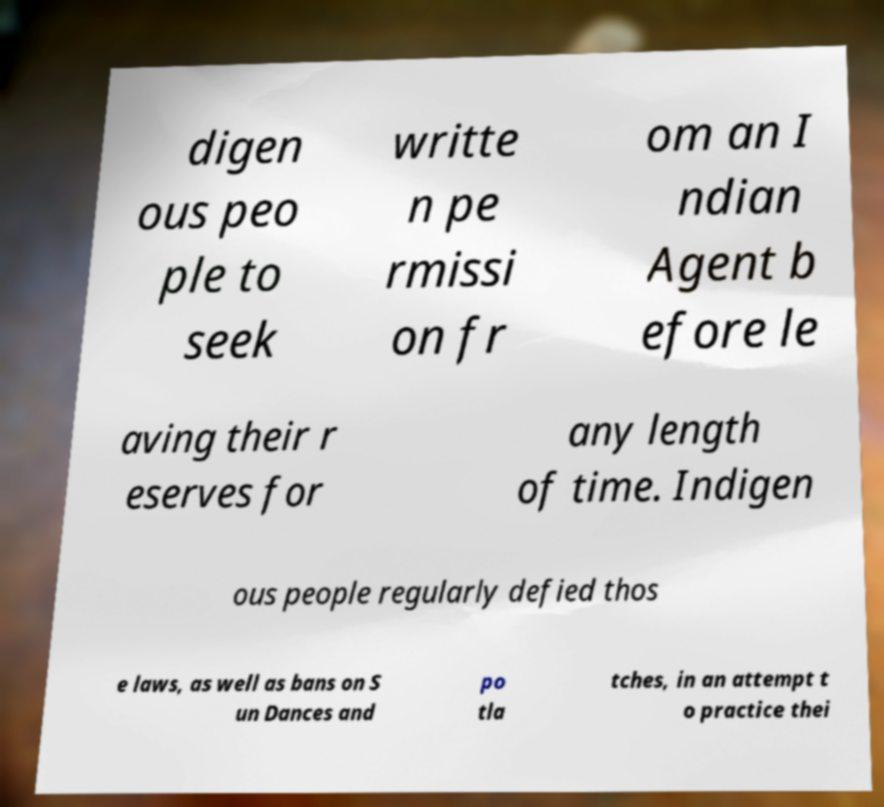Can you read and provide the text displayed in the image?This photo seems to have some interesting text. Can you extract and type it out for me? digen ous peo ple to seek writte n pe rmissi on fr om an I ndian Agent b efore le aving their r eserves for any length of time. Indigen ous people regularly defied thos e laws, as well as bans on S un Dances and po tla tches, in an attempt t o practice thei 